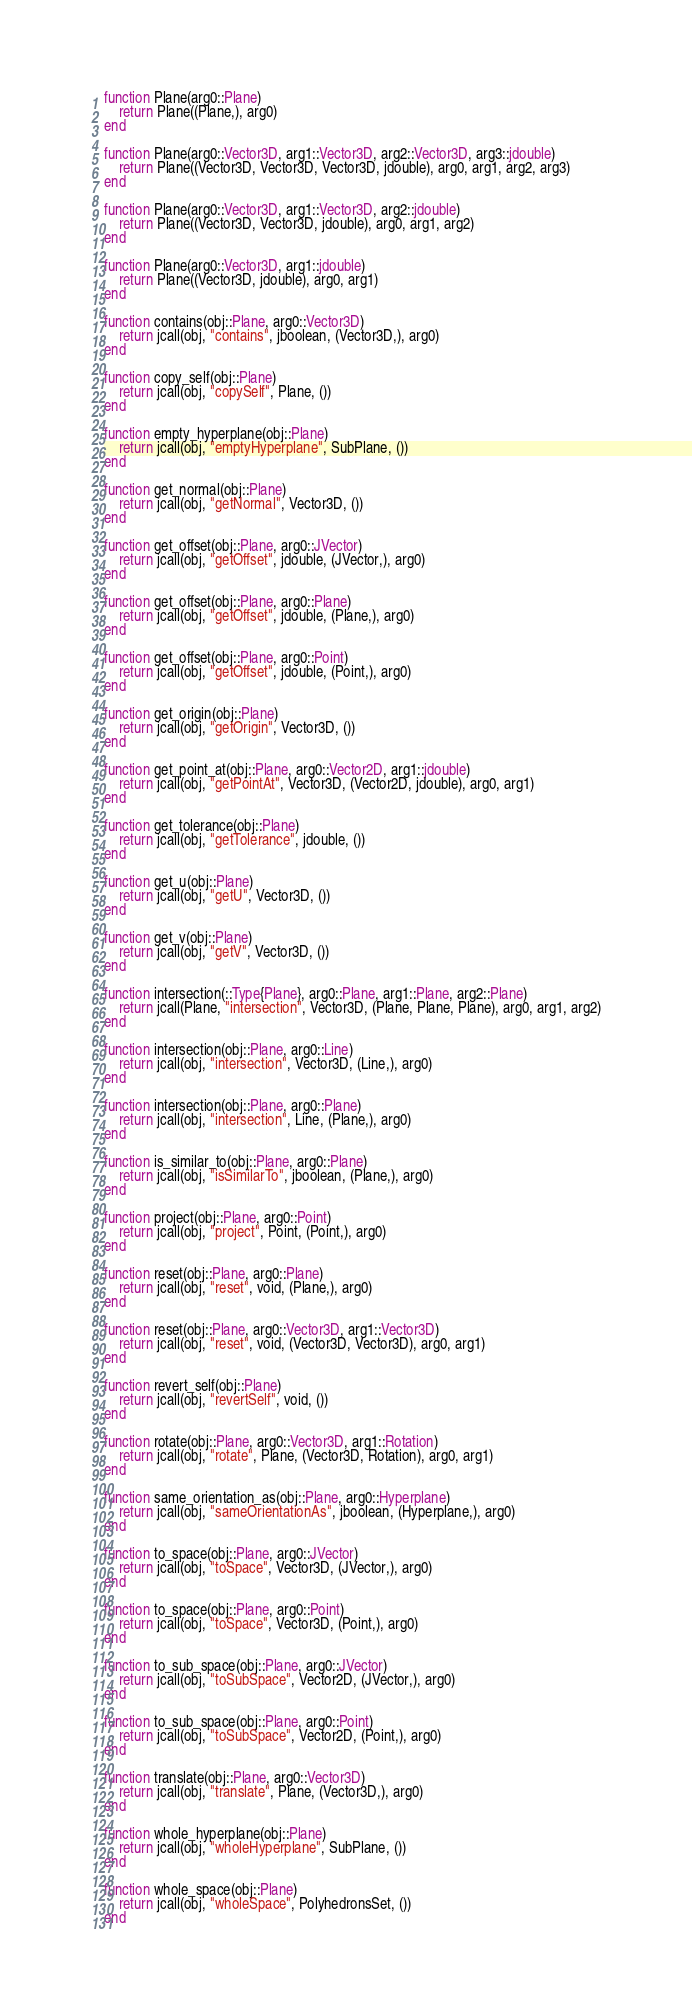Convert code to text. <code><loc_0><loc_0><loc_500><loc_500><_Julia_>function Plane(arg0::Plane)
    return Plane((Plane,), arg0)
end

function Plane(arg0::Vector3D, arg1::Vector3D, arg2::Vector3D, arg3::jdouble)
    return Plane((Vector3D, Vector3D, Vector3D, jdouble), arg0, arg1, arg2, arg3)
end

function Plane(arg0::Vector3D, arg1::Vector3D, arg2::jdouble)
    return Plane((Vector3D, Vector3D, jdouble), arg0, arg1, arg2)
end

function Plane(arg0::Vector3D, arg1::jdouble)
    return Plane((Vector3D, jdouble), arg0, arg1)
end

function contains(obj::Plane, arg0::Vector3D)
    return jcall(obj, "contains", jboolean, (Vector3D,), arg0)
end

function copy_self(obj::Plane)
    return jcall(obj, "copySelf", Plane, ())
end

function empty_hyperplane(obj::Plane)
    return jcall(obj, "emptyHyperplane", SubPlane, ())
end

function get_normal(obj::Plane)
    return jcall(obj, "getNormal", Vector3D, ())
end

function get_offset(obj::Plane, arg0::JVector)
    return jcall(obj, "getOffset", jdouble, (JVector,), arg0)
end

function get_offset(obj::Plane, arg0::Plane)
    return jcall(obj, "getOffset", jdouble, (Plane,), arg0)
end

function get_offset(obj::Plane, arg0::Point)
    return jcall(obj, "getOffset", jdouble, (Point,), arg0)
end

function get_origin(obj::Plane)
    return jcall(obj, "getOrigin", Vector3D, ())
end

function get_point_at(obj::Plane, arg0::Vector2D, arg1::jdouble)
    return jcall(obj, "getPointAt", Vector3D, (Vector2D, jdouble), arg0, arg1)
end

function get_tolerance(obj::Plane)
    return jcall(obj, "getTolerance", jdouble, ())
end

function get_u(obj::Plane)
    return jcall(obj, "getU", Vector3D, ())
end

function get_v(obj::Plane)
    return jcall(obj, "getV", Vector3D, ())
end

function intersection(::Type{Plane}, arg0::Plane, arg1::Plane, arg2::Plane)
    return jcall(Plane, "intersection", Vector3D, (Plane, Plane, Plane), arg0, arg1, arg2)
end

function intersection(obj::Plane, arg0::Line)
    return jcall(obj, "intersection", Vector3D, (Line,), arg0)
end

function intersection(obj::Plane, arg0::Plane)
    return jcall(obj, "intersection", Line, (Plane,), arg0)
end

function is_similar_to(obj::Plane, arg0::Plane)
    return jcall(obj, "isSimilarTo", jboolean, (Plane,), arg0)
end

function project(obj::Plane, arg0::Point)
    return jcall(obj, "project", Point, (Point,), arg0)
end

function reset(obj::Plane, arg0::Plane)
    return jcall(obj, "reset", void, (Plane,), arg0)
end

function reset(obj::Plane, arg0::Vector3D, arg1::Vector3D)
    return jcall(obj, "reset", void, (Vector3D, Vector3D), arg0, arg1)
end

function revert_self(obj::Plane)
    return jcall(obj, "revertSelf", void, ())
end

function rotate(obj::Plane, arg0::Vector3D, arg1::Rotation)
    return jcall(obj, "rotate", Plane, (Vector3D, Rotation), arg0, arg1)
end

function same_orientation_as(obj::Plane, arg0::Hyperplane)
    return jcall(obj, "sameOrientationAs", jboolean, (Hyperplane,), arg0)
end

function to_space(obj::Plane, arg0::JVector)
    return jcall(obj, "toSpace", Vector3D, (JVector,), arg0)
end

function to_space(obj::Plane, arg0::Point)
    return jcall(obj, "toSpace", Vector3D, (Point,), arg0)
end

function to_sub_space(obj::Plane, arg0::JVector)
    return jcall(obj, "toSubSpace", Vector2D, (JVector,), arg0)
end

function to_sub_space(obj::Plane, arg0::Point)
    return jcall(obj, "toSubSpace", Vector2D, (Point,), arg0)
end

function translate(obj::Plane, arg0::Vector3D)
    return jcall(obj, "translate", Plane, (Vector3D,), arg0)
end

function whole_hyperplane(obj::Plane)
    return jcall(obj, "wholeHyperplane", SubPlane, ())
end

function whole_space(obj::Plane)
    return jcall(obj, "wholeSpace", PolyhedronsSet, ())
end

</code> 